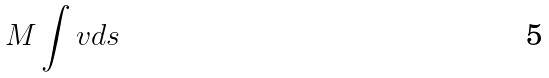<formula> <loc_0><loc_0><loc_500><loc_500>M \int v d s</formula> 